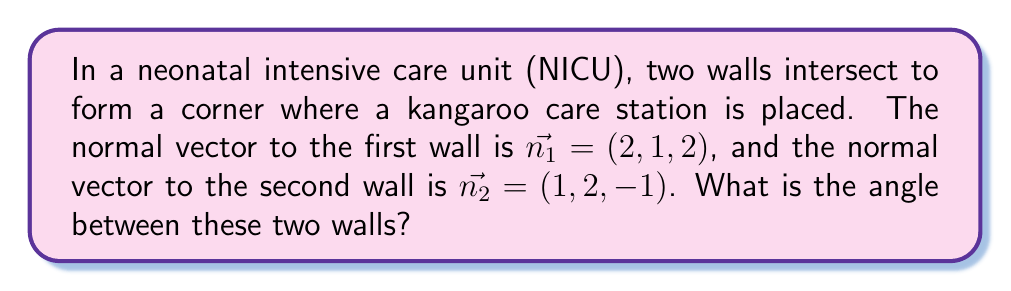Can you answer this question? To find the angle between two intersecting planes, we can use the dot product of their normal vectors. The formula for the angle $\theta$ between two planes is:

$$\cos \theta = \frac{|\vec{n_1} \cdot \vec{n_2}|}{\|\vec{n_1}\| \|\vec{n_2}\|}$$

Step 1: Calculate the dot product of the normal vectors.
$\vec{n_1} \cdot \vec{n_2} = (2)(1) + (1)(2) + (2)(-1) = 2 + 2 - 2 = 2$

Step 2: Calculate the magnitudes of the normal vectors.
$\|\vec{n_1}\| = \sqrt{2^2 + 1^2 + 2^2} = \sqrt{9} = 3$
$\|\vec{n_2}\| = \sqrt{1^2 + 2^2 + (-1)^2} = \sqrt{6}$

Step 3: Substitute the values into the formula.
$$\cos \theta = \frac{|2|}{3 \sqrt{6}}$$

Step 4: Take the inverse cosine (arccos) of both sides.
$$\theta = \arccos\left(\frac{2}{3\sqrt{6}}\right)$$

Step 5: Calculate the final result.
$\theta \approx 1.2490$ radians or $71.57°$
Answer: $\arccos\left(\frac{2}{3\sqrt{6}}\right) \approx 71.57°$ 